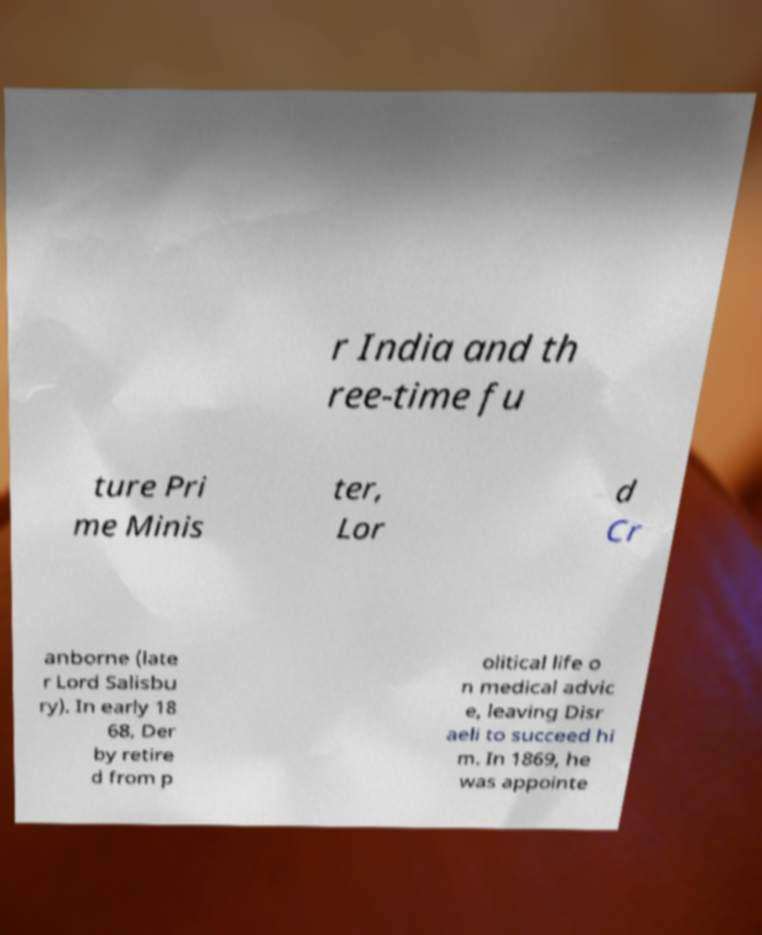Can you read and provide the text displayed in the image?This photo seems to have some interesting text. Can you extract and type it out for me? r India and th ree-time fu ture Pri me Minis ter, Lor d Cr anborne (late r Lord Salisbu ry). In early 18 68, Der by retire d from p olitical life o n medical advic e, leaving Disr aeli to succeed hi m. In 1869, he was appointe 